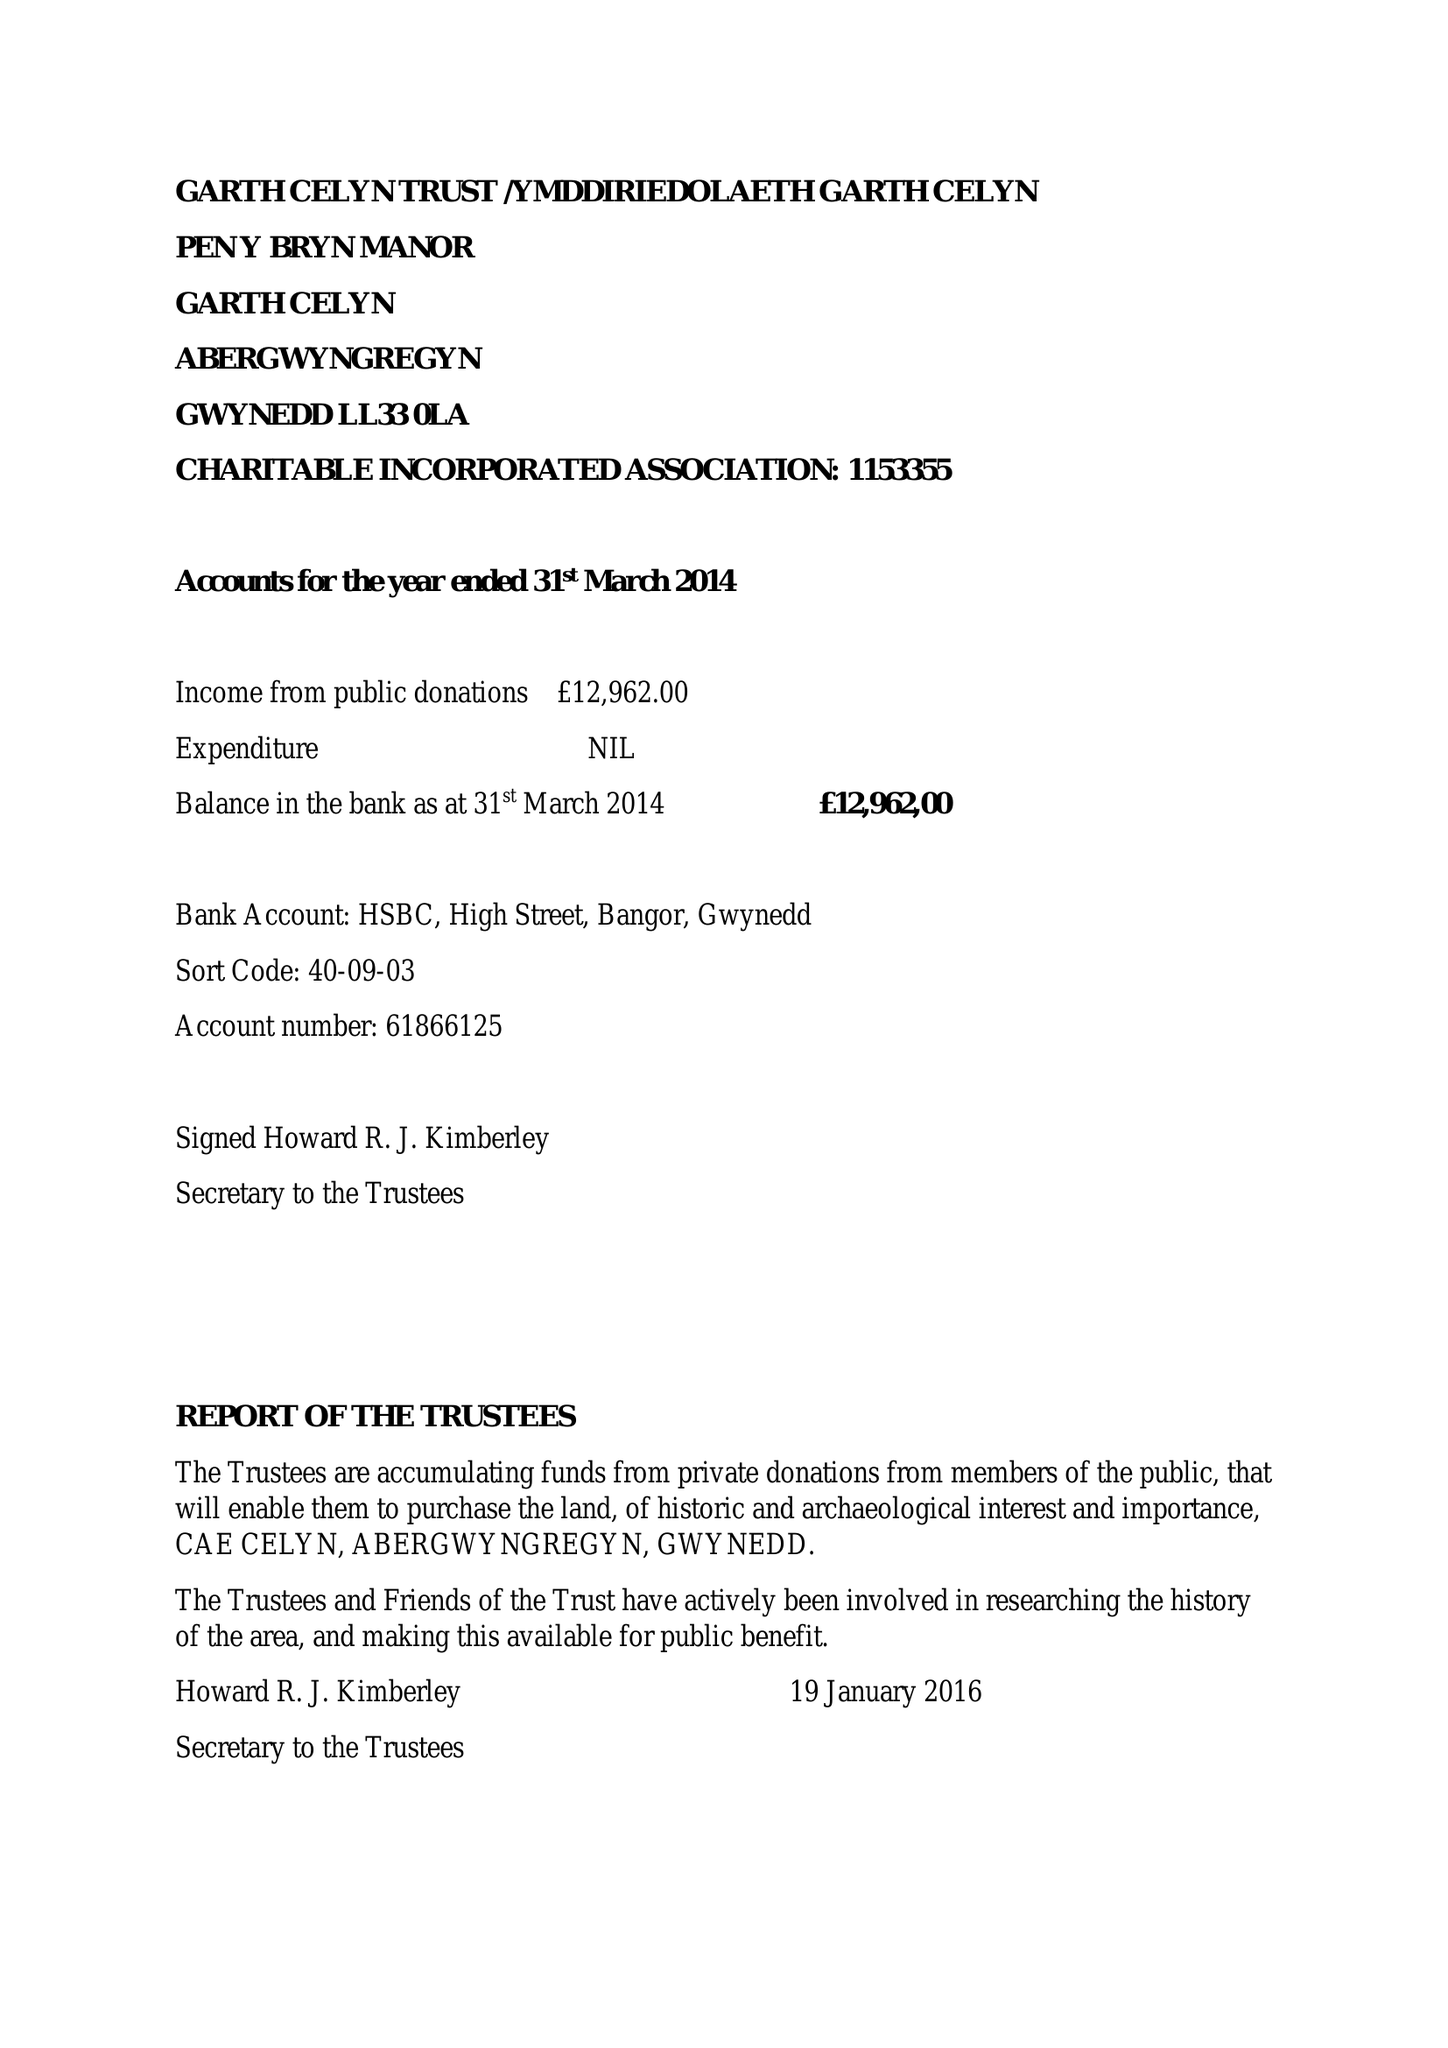What is the value for the report_date?
Answer the question using a single word or phrase. 2015-03-31 